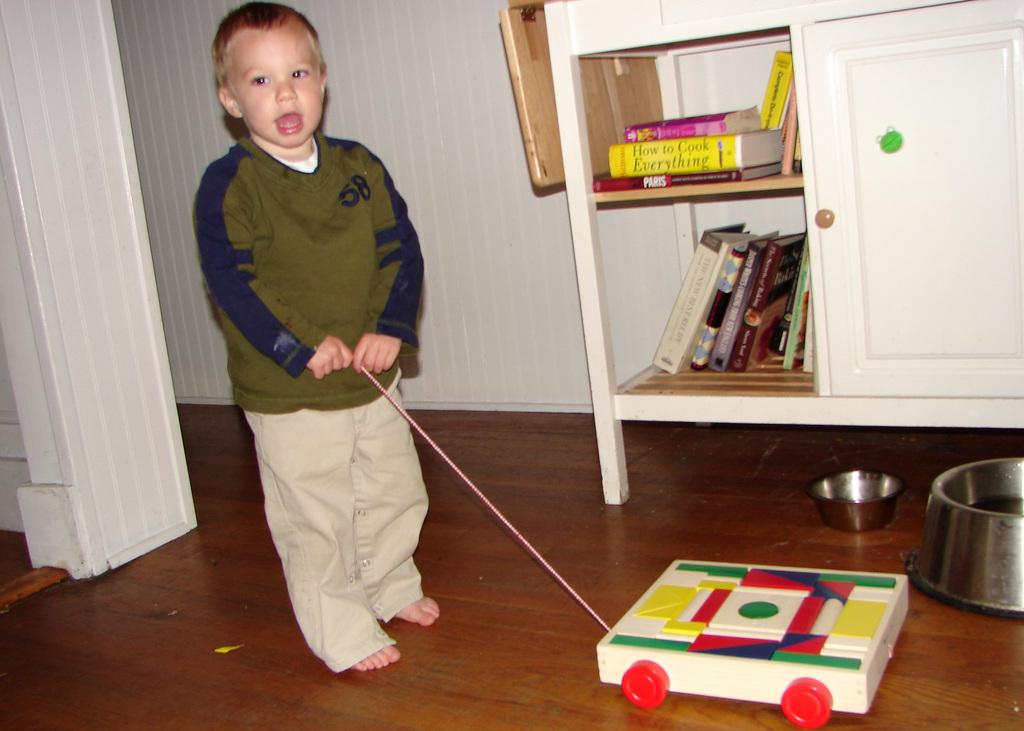Who is the main subject in the image? There is a boy in the image. What is the boy doing in the image? The boy is standing and pulling a trolley toy with a string. Where are the books located in the image? The books are in a cupboard. How many vessels are visible in the image? There are two vessels visible in the image. What type of yarn is the boy using to pull the trolley toy in the image? There is no yarn visible in the image; the boy is using a string to pull the trolley toy. How many people are in the crowd in the image? There is no crowd present in the image; it only features a boy and his trolley toy. 